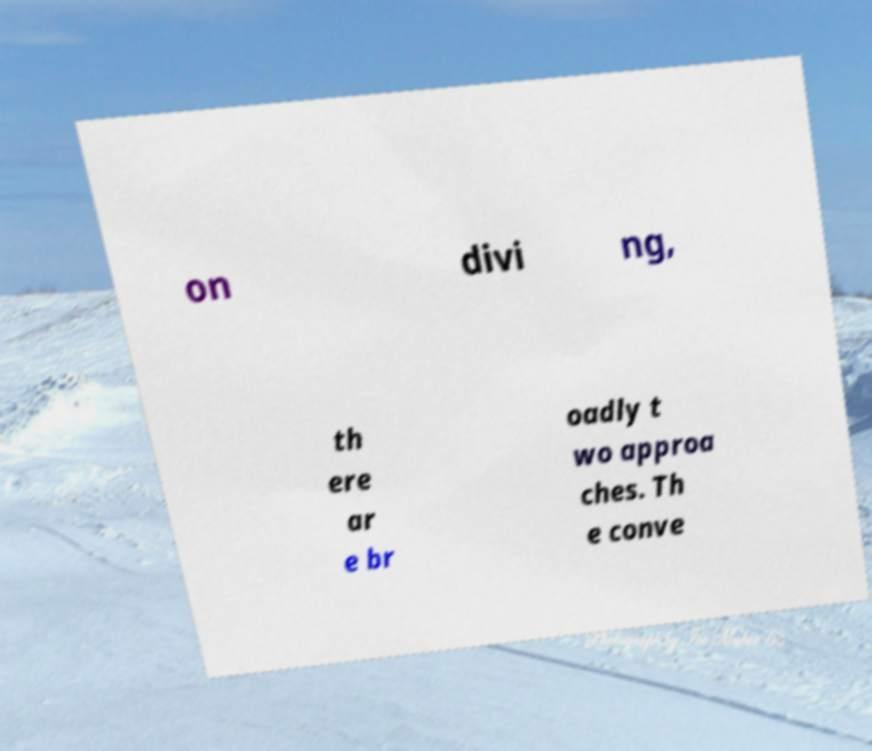Can you accurately transcribe the text from the provided image for me? on divi ng, th ere ar e br oadly t wo approa ches. Th e conve 